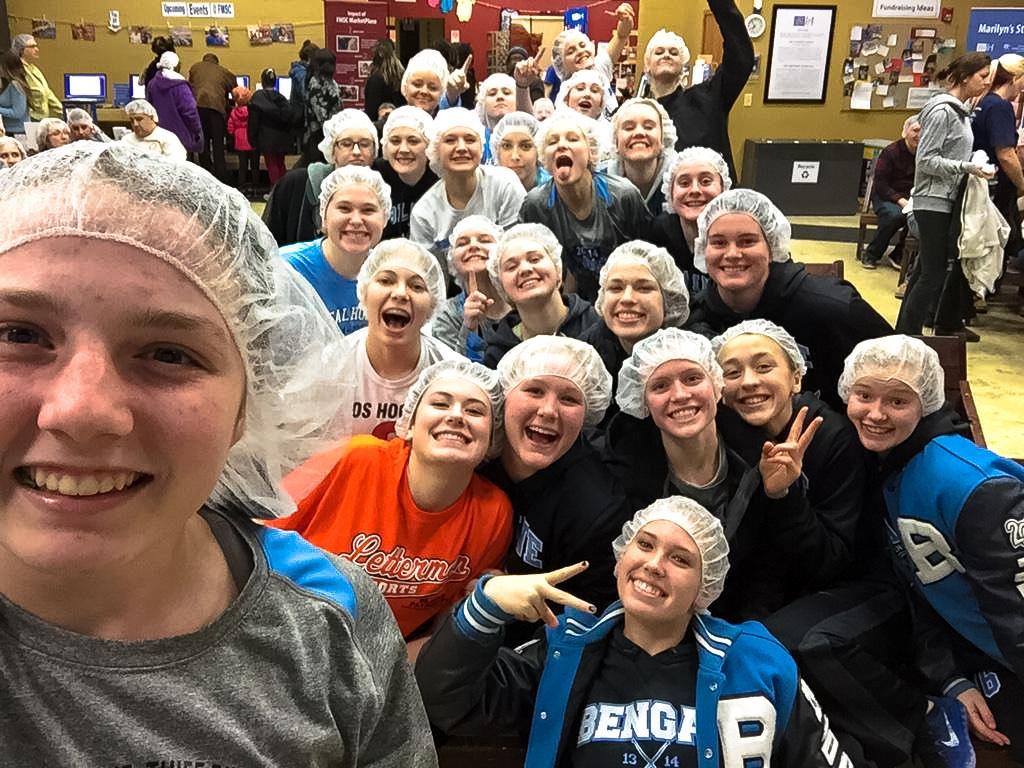Describe this image in one or two sentences. Here I can see a crowd of people wearing t-shirts, caps on the heads, smiling and giving pose for the picture. On the right side, I can see a person is sitting on the chair and few people are walking on the ground. In the background there are some more people are standing in front of the monitors. On the top of the image there is a wall on which a frame, photos and some posters are attached. 